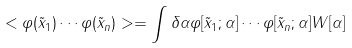Convert formula to latex. <formula><loc_0><loc_0><loc_500><loc_500>< \varphi ( \tilde { x } _ { 1 } ) \cdots \varphi ( \tilde { x } _ { n } ) > = \int \delta \alpha \varphi [ \tilde { x } _ { 1 } ; \alpha ] \cdots \varphi [ \tilde { x } _ { n } ; \alpha ] W [ \alpha ]</formula> 